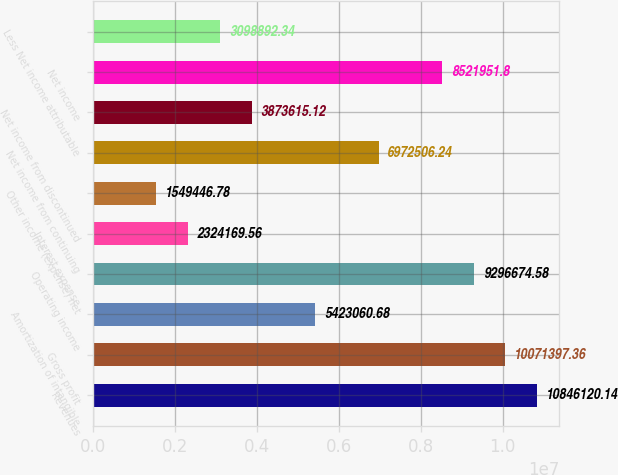Convert chart. <chart><loc_0><loc_0><loc_500><loc_500><bar_chart><fcel>Revenues<fcel>Gross profit<fcel>Amortization of intangible<fcel>Operating income<fcel>Interest expense<fcel>Other income (expense) net<fcel>Net income from continuing<fcel>Net income from discontinued<fcel>Net income<fcel>Less Net income attributable<nl><fcel>1.08461e+07<fcel>1.00714e+07<fcel>5.42306e+06<fcel>9.29667e+06<fcel>2.32417e+06<fcel>1.54945e+06<fcel>6.97251e+06<fcel>3.87362e+06<fcel>8.52195e+06<fcel>3.09889e+06<nl></chart> 